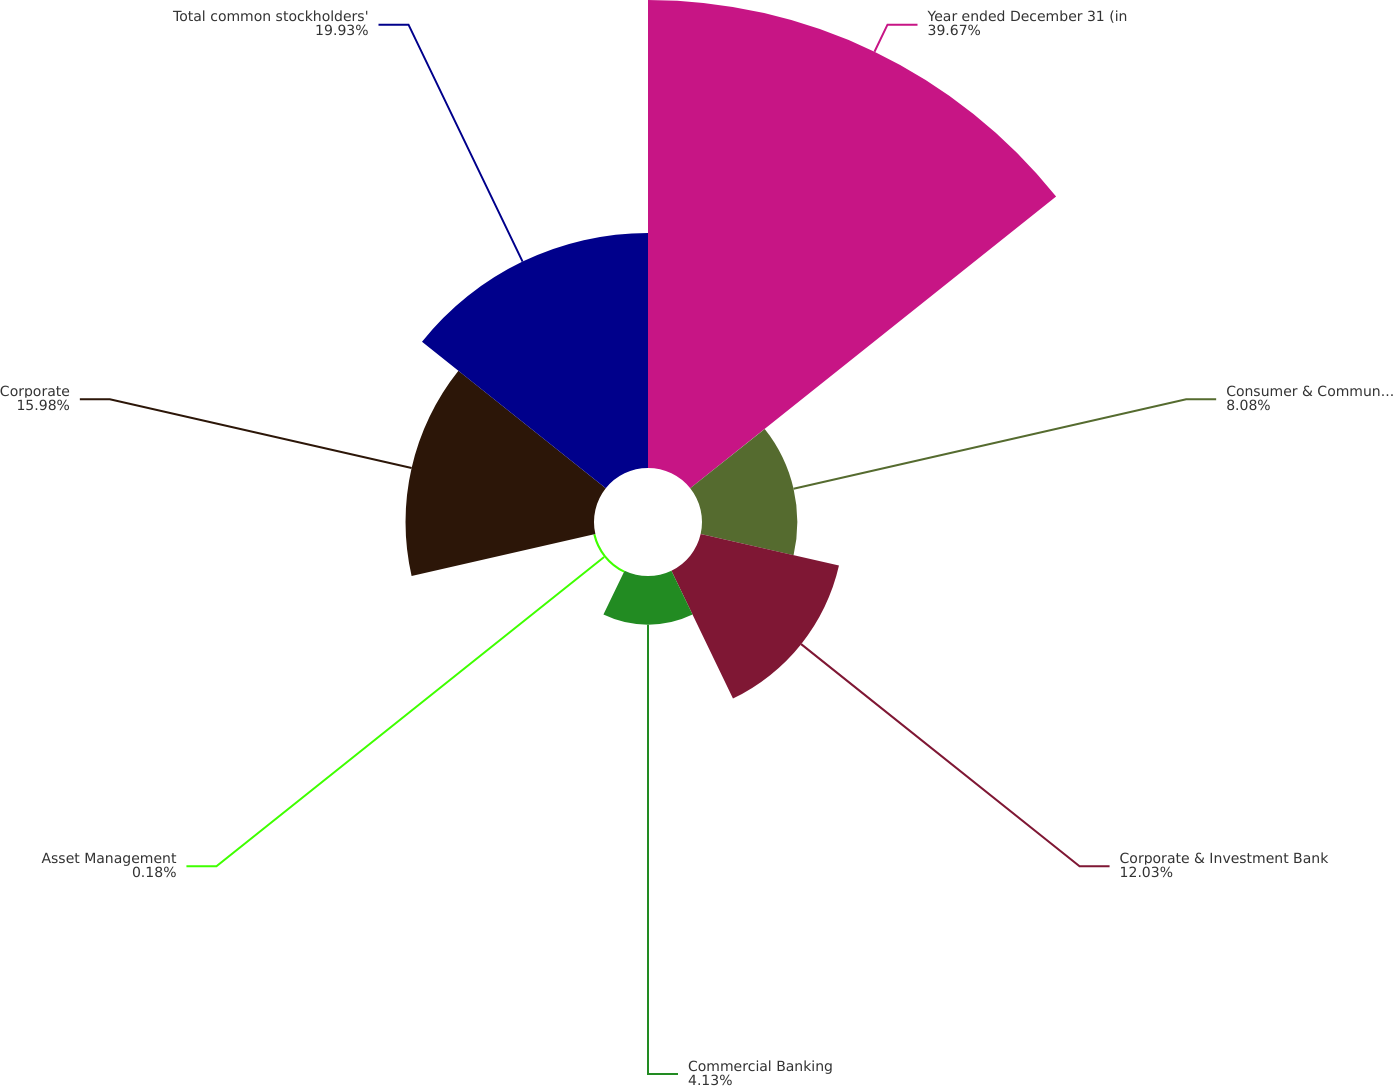Convert chart to OTSL. <chart><loc_0><loc_0><loc_500><loc_500><pie_chart><fcel>Year ended December 31 (in<fcel>Consumer & Community Banking<fcel>Corporate & Investment Bank<fcel>Commercial Banking<fcel>Asset Management<fcel>Corporate<fcel>Total common stockholders'<nl><fcel>39.68%<fcel>8.08%<fcel>12.03%<fcel>4.13%<fcel>0.18%<fcel>15.98%<fcel>19.93%<nl></chart> 